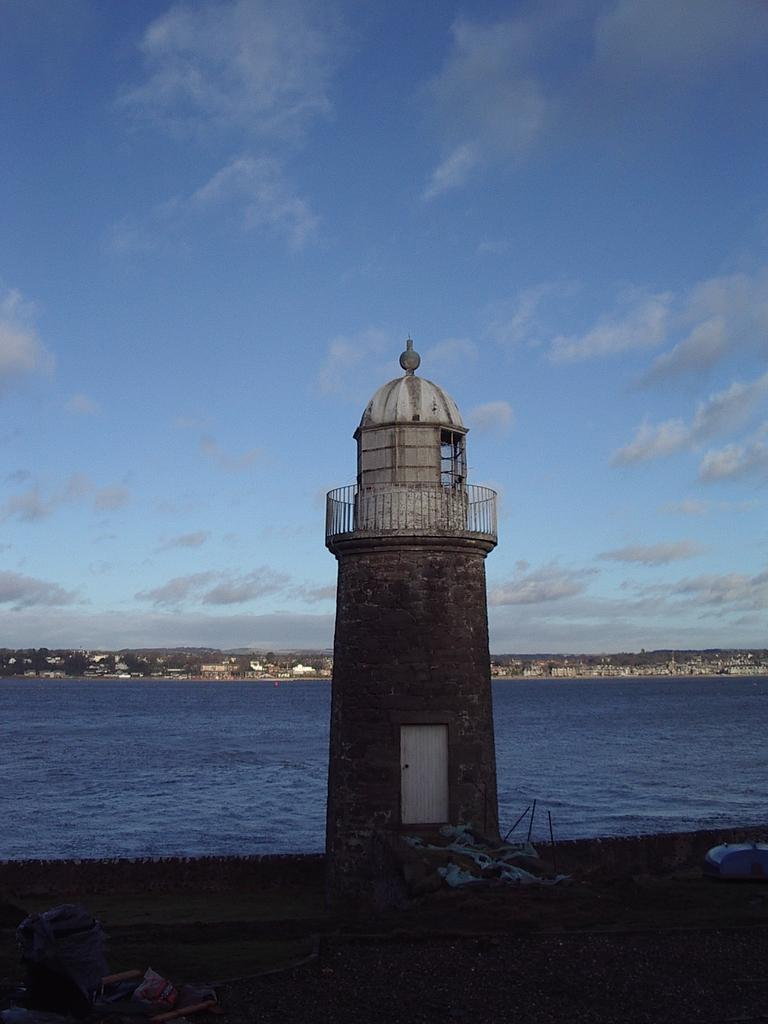What is the main structure in the image? There is a lighthouse in the image. What feature is present near the lighthouse? There is a door in the image. What safety feature can be seen in the image? There is railing in the image. What type of structure is depicted in the image? There are walls in the image. What objects are visible at the bottom of the image? There are objects at the bottom of the image. What is visible in the background of the image? The background of the image includes water, houses, trees, and the sky. Can you tell me what instrument the person is playing in the image? There is no person present in the image, and therefore no instrument can be observed. How many wheels are visible on the lighthouse in the image? The lighthouse in the image does not have any wheels. 